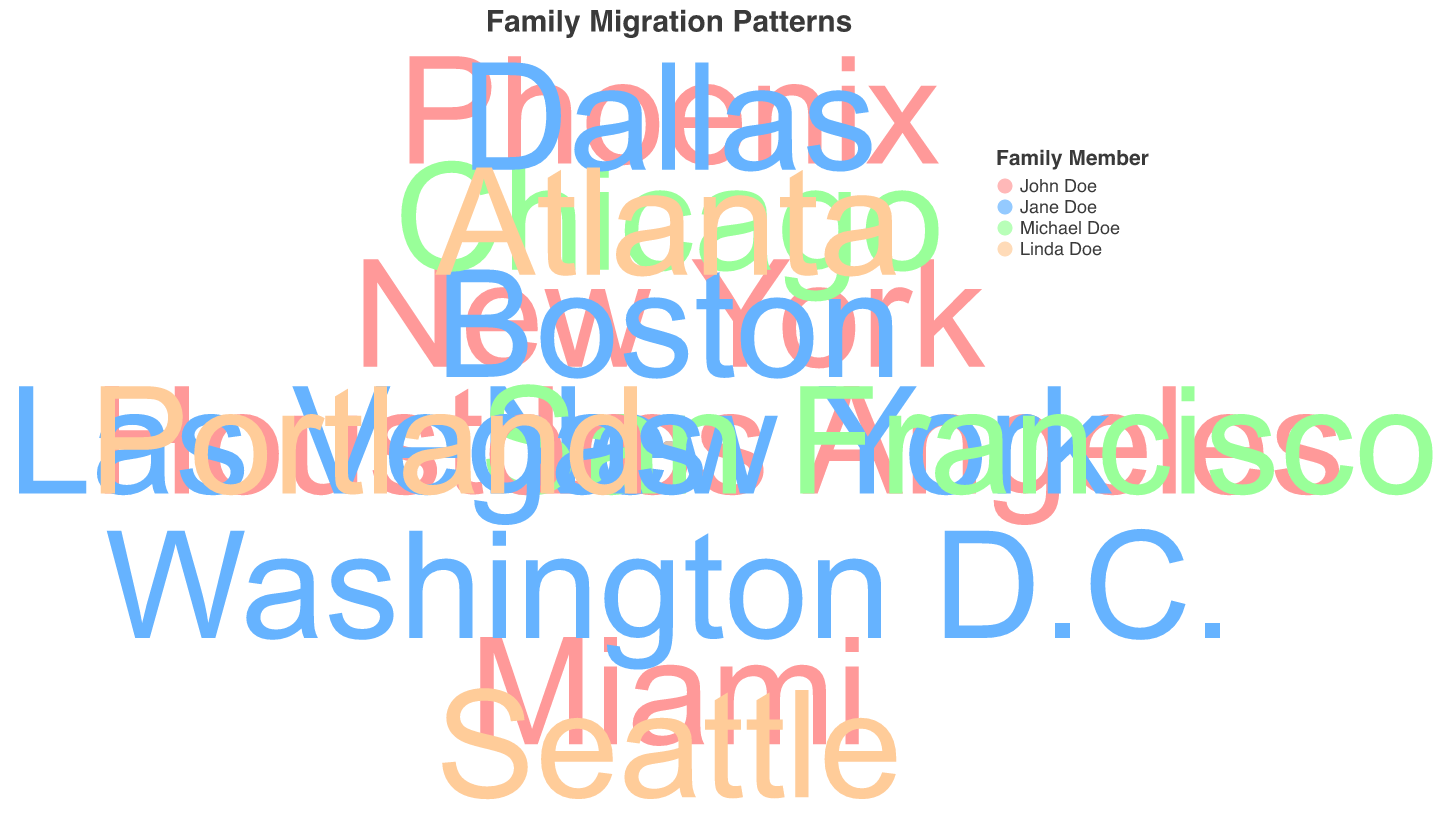How many family members are represented in the chart? The chart legend shows symbols for four family members: John Doe, Jane Doe, Michael Doe, and Linda Doe, with each having a distinct color.
Answer: 4 Which family member moved the farthest from hometown in 2020? By looking at the radius for 2020, we identify the largest radius for that year. John Doe moved to Phoenix with a distance of 2400 units from the hometown, which is the farthest.
Answer: John Doe In 1990, which family member had the shortest distance from their hometown? In 1990, the smallest radius indicates the shortest distance. Jane Doe, who moved to New York, had the smallest distance of 250 units.
Answer: Jane Doe How did the average distance from hometown for John Doe change from 1980 to 2020? Calculate the distances for John Doe in each year: (1980: 250, 1990: 1500, 2000: 1300, 2010: 1900, 2020: 2400). The average in 1980 is 250, while the average in 2020 is (250 + 1500 + 1300 + 1900 + 2400) / 5 = 13270 / 5 = 1454.
Answer: Increased Compare the movement patterns of Michael Doe and Linda Doe. How are they different? Michael Doe is present only up to 1990, moving from Chicago to San Francisco, with increasing distances from 1000 to 1800. Linda Doe appears from 2000 onward, moving from Seattle to Atlanta, with varying distances from 2000 to 950. Michael's pattern shows a consistent increase, whereas Linda's distances vary widely.
Answer: Michael increases, Linda varies What trend can you observe about Jane Doe's migration pattern over the years? In the chart, Jane Doe initially moves from Boston (1980) to New York (1990), then to Washington D.C. (2000), Las Vegas (2010), and finally to Dallas (2020). The distance from hometown shows an increasing pattern: 200, 250, 350, 2100, 2300.
Answer: Increasing distances Which year saw the most significant movement from the hometown for all family members combined? Compare sum of distances for all family members in each year: 1980 (250+200+1000), 1990 (1500+250+1800), 2000 (1300+350+2000), 2010 (1900+2100+1950), 2020 (2400+2300+950). The year 2010 has the highest total movement: 1900+2100+1950=5950.
Answer: 2010 What locations did Jane Doe reside in throughout the years, and how did her distances change? Jane Doe lived in Boston (1980), New York (1990), Washington D.C. (2000), Las Vegas (2010), and Dallas (2020). Her distances went 200 (1980), 250 (1990), 350 (2000), 2100 (2010), and 2300 (2020), showing an increase over time.
Answer: Boston, New York, Washington D.C., Las Vegas, Dallas; Increasing distances 